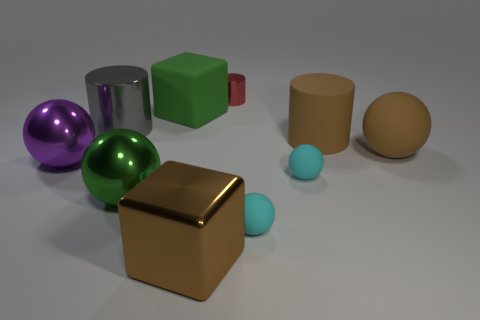What materials do the objects seem to be made from? The objects appear to have various materials. The shiny purple and green spheres look metallic, the cubes seem to be matte and could be plastic, and the cylinder and egg-shaped objects have a more muted, possibly clay-like texture. 